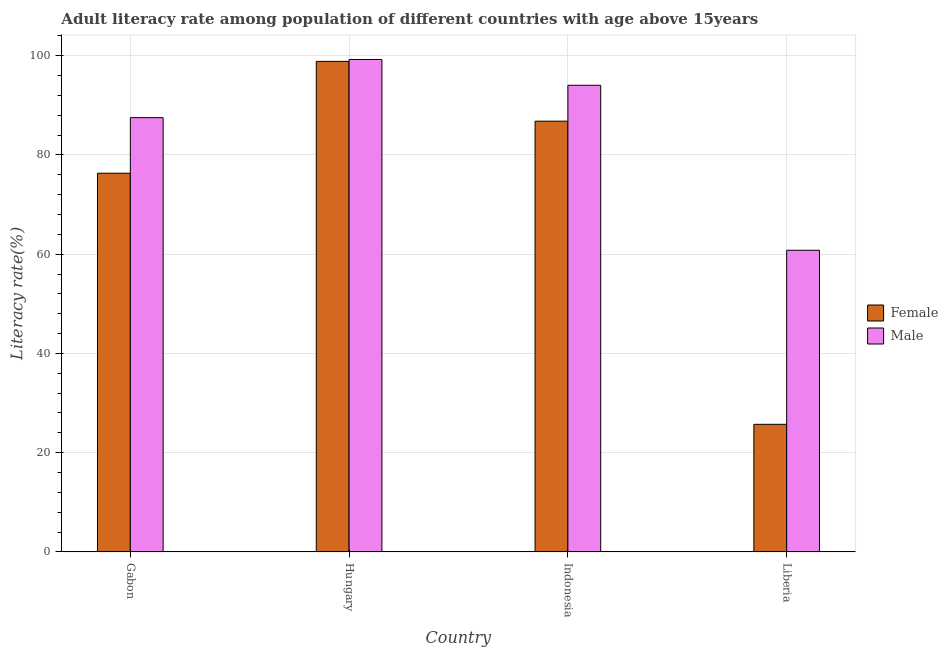How many groups of bars are there?
Keep it short and to the point. 4. Are the number of bars per tick equal to the number of legend labels?
Keep it short and to the point. Yes. Are the number of bars on each tick of the X-axis equal?
Offer a very short reply. Yes. What is the label of the 2nd group of bars from the left?
Your answer should be compact. Hungary. In how many cases, is the number of bars for a given country not equal to the number of legend labels?
Give a very brief answer. 0. What is the male adult literacy rate in Hungary?
Ensure brevity in your answer.  99.23. Across all countries, what is the maximum female adult literacy rate?
Keep it short and to the point. 98.85. Across all countries, what is the minimum male adult literacy rate?
Your answer should be compact. 60.78. In which country was the female adult literacy rate maximum?
Provide a succinct answer. Hungary. In which country was the male adult literacy rate minimum?
Your answer should be very brief. Liberia. What is the total female adult literacy rate in the graph?
Keep it short and to the point. 287.67. What is the difference between the male adult literacy rate in Hungary and that in Liberia?
Ensure brevity in your answer.  38.45. What is the difference between the female adult literacy rate in Liberia and the male adult literacy rate in Gabon?
Make the answer very short. -61.8. What is the average female adult literacy rate per country?
Offer a terse response. 71.92. What is the difference between the male adult literacy rate and female adult literacy rate in Indonesia?
Offer a very short reply. 7.24. In how many countries, is the female adult literacy rate greater than 64 %?
Your response must be concise. 3. What is the ratio of the female adult literacy rate in Indonesia to that in Liberia?
Give a very brief answer. 3.38. Is the difference between the female adult literacy rate in Hungary and Indonesia greater than the difference between the male adult literacy rate in Hungary and Indonesia?
Provide a short and direct response. Yes. What is the difference between the highest and the second highest male adult literacy rate?
Your answer should be very brief. 5.19. What is the difference between the highest and the lowest male adult literacy rate?
Offer a very short reply. 38.45. What does the 2nd bar from the right in Liberia represents?
Make the answer very short. Female. Are the values on the major ticks of Y-axis written in scientific E-notation?
Ensure brevity in your answer.  No. Where does the legend appear in the graph?
Give a very brief answer. Center right. How many legend labels are there?
Your response must be concise. 2. How are the legend labels stacked?
Offer a terse response. Vertical. What is the title of the graph?
Offer a very short reply. Adult literacy rate among population of different countries with age above 15years. What is the label or title of the X-axis?
Provide a short and direct response. Country. What is the label or title of the Y-axis?
Your answer should be very brief. Literacy rate(%). What is the Literacy rate(%) in Female in Gabon?
Offer a terse response. 76.31. What is the Literacy rate(%) in Male in Gabon?
Provide a succinct answer. 87.51. What is the Literacy rate(%) of Female in Hungary?
Ensure brevity in your answer.  98.85. What is the Literacy rate(%) of Male in Hungary?
Offer a terse response. 99.23. What is the Literacy rate(%) in Female in Indonesia?
Your answer should be compact. 86.8. What is the Literacy rate(%) in Male in Indonesia?
Your answer should be very brief. 94.04. What is the Literacy rate(%) of Female in Liberia?
Offer a very short reply. 25.71. What is the Literacy rate(%) in Male in Liberia?
Provide a succinct answer. 60.78. Across all countries, what is the maximum Literacy rate(%) of Female?
Ensure brevity in your answer.  98.85. Across all countries, what is the maximum Literacy rate(%) of Male?
Offer a terse response. 99.23. Across all countries, what is the minimum Literacy rate(%) in Female?
Provide a succinct answer. 25.71. Across all countries, what is the minimum Literacy rate(%) of Male?
Keep it short and to the point. 60.78. What is the total Literacy rate(%) in Female in the graph?
Your response must be concise. 287.67. What is the total Literacy rate(%) of Male in the graph?
Provide a succinct answer. 341.56. What is the difference between the Literacy rate(%) in Female in Gabon and that in Hungary?
Offer a terse response. -22.55. What is the difference between the Literacy rate(%) in Male in Gabon and that in Hungary?
Keep it short and to the point. -11.72. What is the difference between the Literacy rate(%) of Female in Gabon and that in Indonesia?
Provide a succinct answer. -10.49. What is the difference between the Literacy rate(%) in Male in Gabon and that in Indonesia?
Give a very brief answer. -6.53. What is the difference between the Literacy rate(%) of Female in Gabon and that in Liberia?
Offer a terse response. 50.6. What is the difference between the Literacy rate(%) in Male in Gabon and that in Liberia?
Make the answer very short. 26.72. What is the difference between the Literacy rate(%) in Female in Hungary and that in Indonesia?
Offer a very short reply. 12.05. What is the difference between the Literacy rate(%) of Male in Hungary and that in Indonesia?
Provide a succinct answer. 5.19. What is the difference between the Literacy rate(%) in Female in Hungary and that in Liberia?
Give a very brief answer. 73.15. What is the difference between the Literacy rate(%) of Male in Hungary and that in Liberia?
Ensure brevity in your answer.  38.45. What is the difference between the Literacy rate(%) in Female in Indonesia and that in Liberia?
Your response must be concise. 61.09. What is the difference between the Literacy rate(%) in Male in Indonesia and that in Liberia?
Make the answer very short. 33.25. What is the difference between the Literacy rate(%) of Female in Gabon and the Literacy rate(%) of Male in Hungary?
Provide a succinct answer. -22.92. What is the difference between the Literacy rate(%) in Female in Gabon and the Literacy rate(%) in Male in Indonesia?
Your answer should be compact. -17.73. What is the difference between the Literacy rate(%) in Female in Gabon and the Literacy rate(%) in Male in Liberia?
Provide a short and direct response. 15.52. What is the difference between the Literacy rate(%) of Female in Hungary and the Literacy rate(%) of Male in Indonesia?
Give a very brief answer. 4.82. What is the difference between the Literacy rate(%) of Female in Hungary and the Literacy rate(%) of Male in Liberia?
Your answer should be compact. 38.07. What is the difference between the Literacy rate(%) of Female in Indonesia and the Literacy rate(%) of Male in Liberia?
Your answer should be very brief. 26.02. What is the average Literacy rate(%) in Female per country?
Offer a very short reply. 71.92. What is the average Literacy rate(%) of Male per country?
Provide a succinct answer. 85.39. What is the difference between the Literacy rate(%) in Female and Literacy rate(%) in Male in Gabon?
Your answer should be compact. -11.2. What is the difference between the Literacy rate(%) of Female and Literacy rate(%) of Male in Hungary?
Ensure brevity in your answer.  -0.38. What is the difference between the Literacy rate(%) of Female and Literacy rate(%) of Male in Indonesia?
Provide a succinct answer. -7.24. What is the difference between the Literacy rate(%) of Female and Literacy rate(%) of Male in Liberia?
Keep it short and to the point. -35.08. What is the ratio of the Literacy rate(%) in Female in Gabon to that in Hungary?
Make the answer very short. 0.77. What is the ratio of the Literacy rate(%) of Male in Gabon to that in Hungary?
Offer a terse response. 0.88. What is the ratio of the Literacy rate(%) of Female in Gabon to that in Indonesia?
Offer a terse response. 0.88. What is the ratio of the Literacy rate(%) in Male in Gabon to that in Indonesia?
Provide a succinct answer. 0.93. What is the ratio of the Literacy rate(%) of Female in Gabon to that in Liberia?
Provide a succinct answer. 2.97. What is the ratio of the Literacy rate(%) in Male in Gabon to that in Liberia?
Your response must be concise. 1.44. What is the ratio of the Literacy rate(%) in Female in Hungary to that in Indonesia?
Your response must be concise. 1.14. What is the ratio of the Literacy rate(%) of Male in Hungary to that in Indonesia?
Provide a succinct answer. 1.06. What is the ratio of the Literacy rate(%) in Female in Hungary to that in Liberia?
Offer a very short reply. 3.85. What is the ratio of the Literacy rate(%) of Male in Hungary to that in Liberia?
Ensure brevity in your answer.  1.63. What is the ratio of the Literacy rate(%) in Female in Indonesia to that in Liberia?
Your answer should be compact. 3.38. What is the ratio of the Literacy rate(%) in Male in Indonesia to that in Liberia?
Ensure brevity in your answer.  1.55. What is the difference between the highest and the second highest Literacy rate(%) in Female?
Offer a very short reply. 12.05. What is the difference between the highest and the second highest Literacy rate(%) of Male?
Your answer should be compact. 5.19. What is the difference between the highest and the lowest Literacy rate(%) in Female?
Your response must be concise. 73.15. What is the difference between the highest and the lowest Literacy rate(%) in Male?
Give a very brief answer. 38.45. 